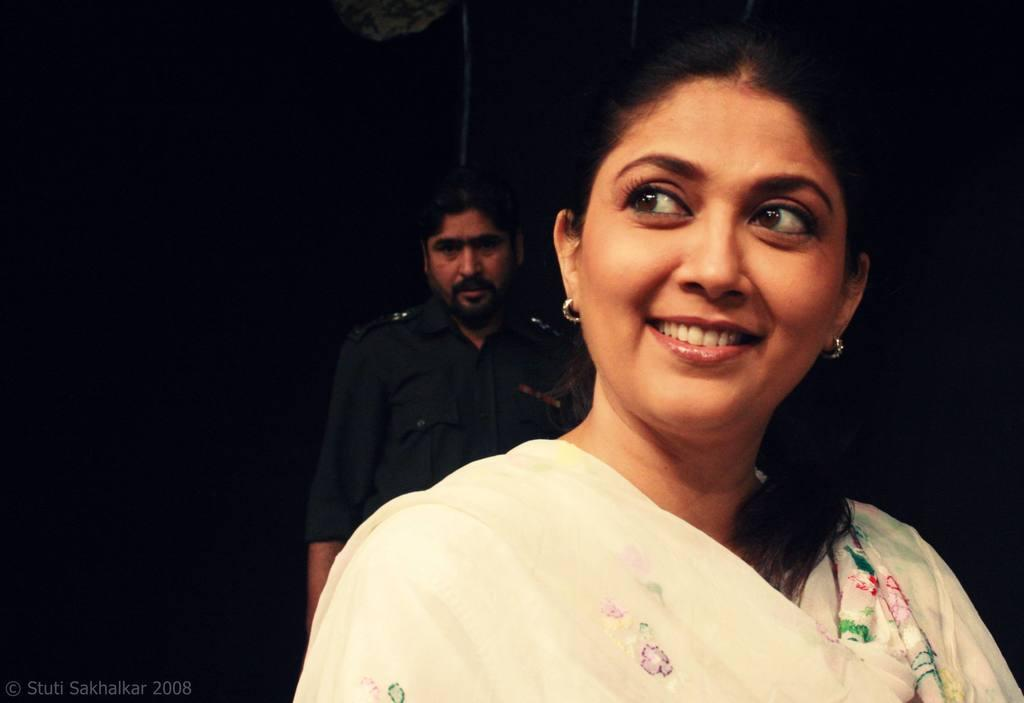Who is present in the image? There is a woman and a man in the image. What is the woman doing in the image? The woman is smiling in the image. What can be observed about the background of the image? The background of the image is dark. Is there any text or marking at the bottom of the image? Yes, there is a watermark at the bottom of the image. What type of town can be seen in the background of the image? There is no town visible in the image; the background is dark. Can you describe the tiger that is interacting with the woman in the image? There is no tiger present in the image; only a woman and a man are visible. 